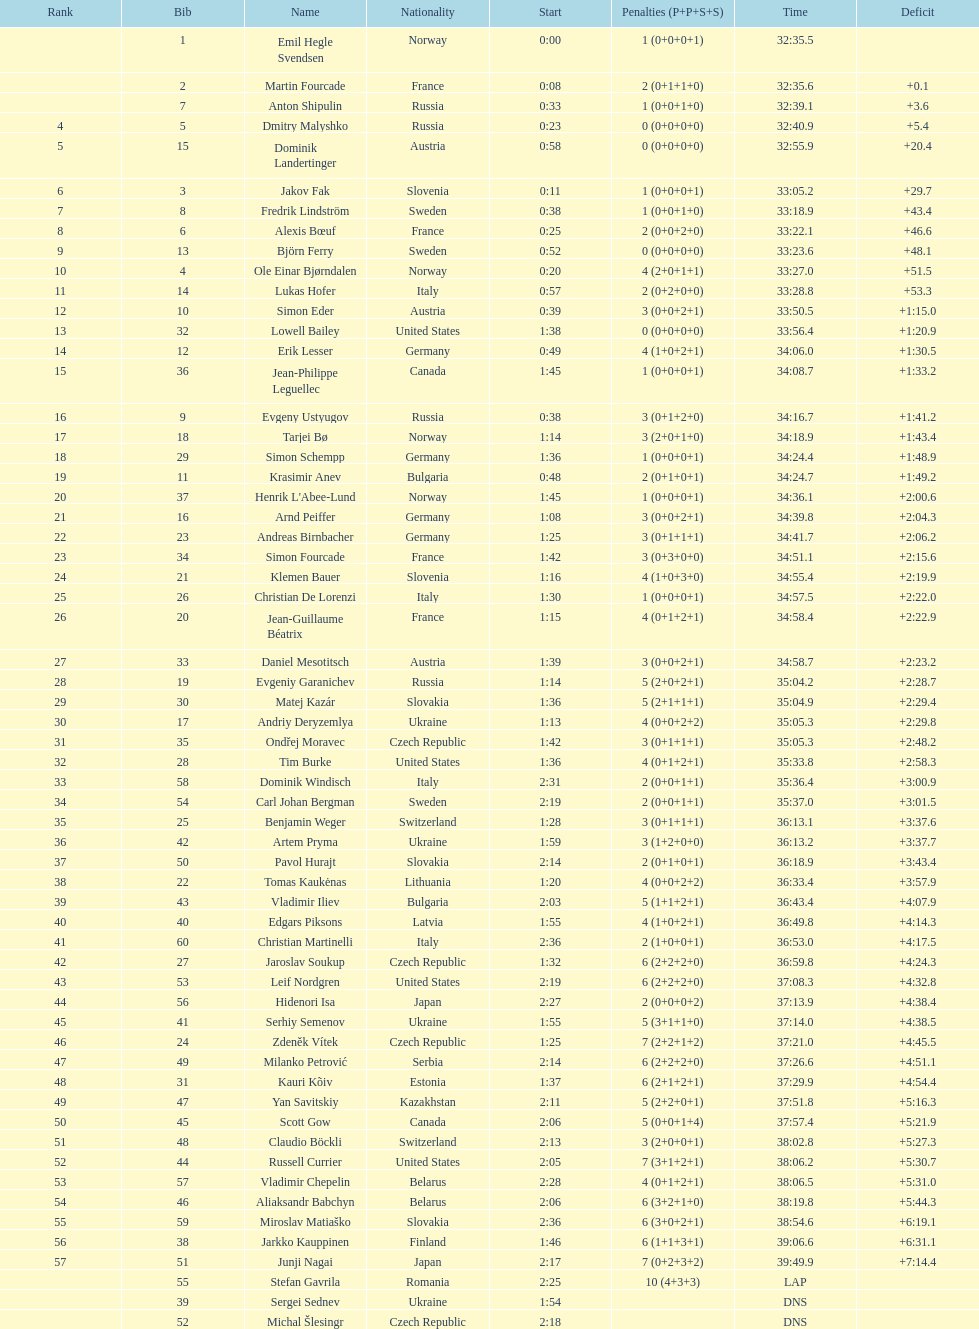How many participants are there in total from both norway and france? 7. 